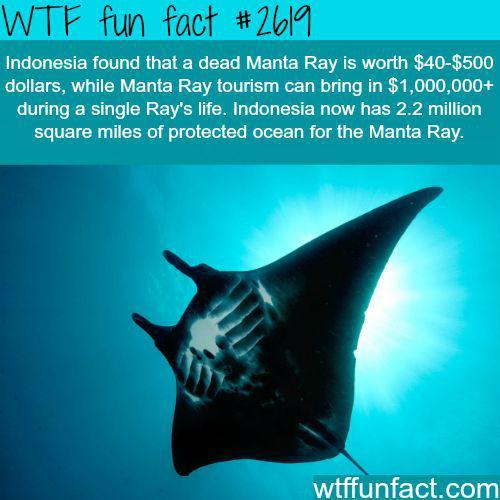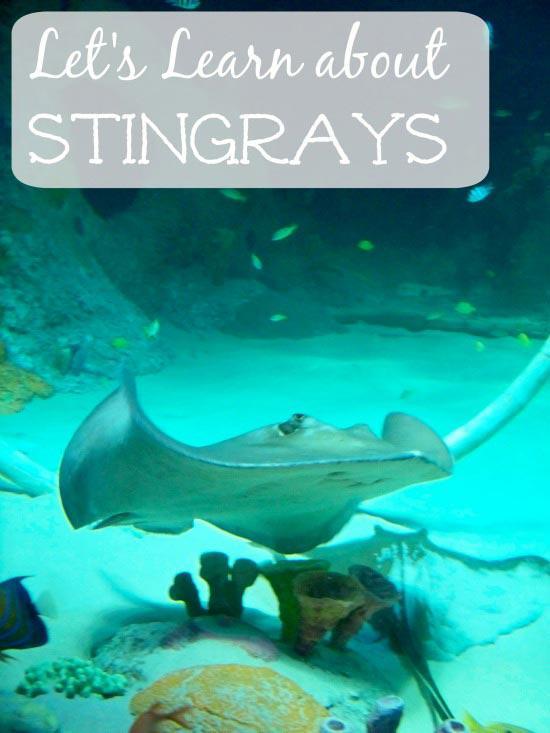The first image is the image on the left, the second image is the image on the right. Given the left and right images, does the statement "There is a human visible in one of the images." hold true? Answer yes or no. No. 